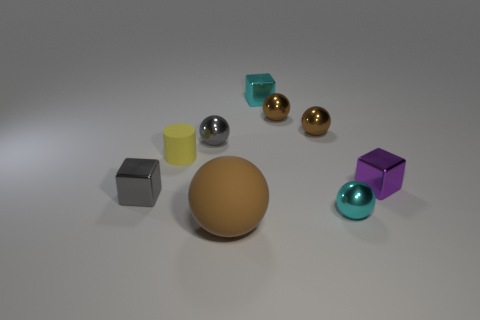Subtract all blue blocks. How many brown spheres are left? 3 Subtract 2 balls. How many balls are left? 3 Subtract all cyan balls. How many balls are left? 4 Subtract all yellow spheres. Subtract all purple cylinders. How many spheres are left? 5 Add 1 gray shiny balls. How many objects exist? 10 Subtract all cylinders. How many objects are left? 8 Subtract all red cylinders. Subtract all small gray shiny objects. How many objects are left? 7 Add 3 small spheres. How many small spheres are left? 7 Add 4 tiny red spheres. How many tiny red spheres exist? 4 Subtract 0 blue blocks. How many objects are left? 9 